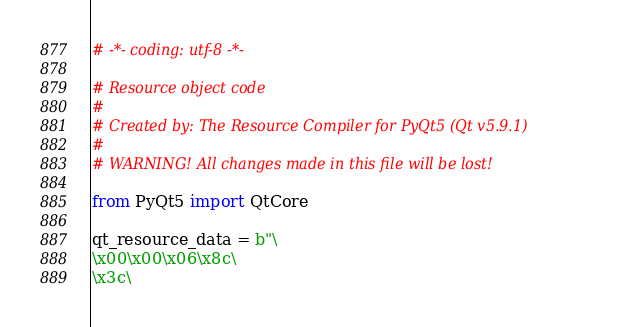<code> <loc_0><loc_0><loc_500><loc_500><_Python_># -*- coding: utf-8 -*-

# Resource object code
#
# Created by: The Resource Compiler for PyQt5 (Qt v5.9.1)
#
# WARNING! All changes made in this file will be lost!

from PyQt5 import QtCore

qt_resource_data = b"\
\x00\x00\x06\x8c\
\x3c\</code> 